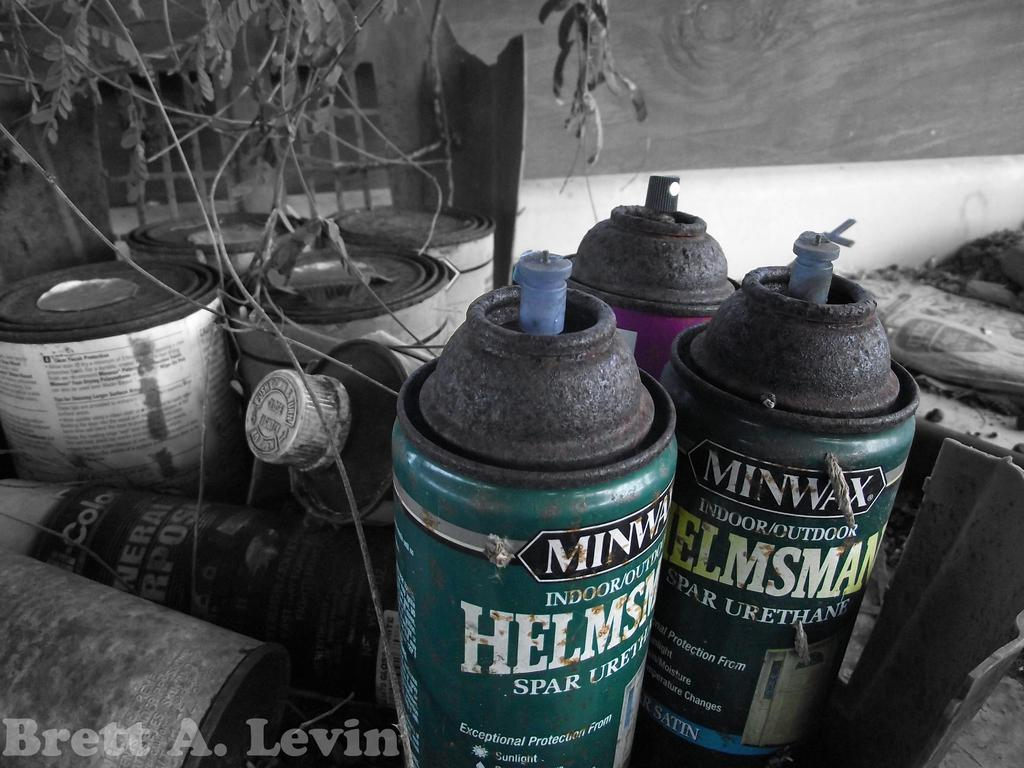Provide a one-sentence caption for the provided image. A few cans of Minwax spray sit near each other. 